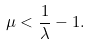<formula> <loc_0><loc_0><loc_500><loc_500>\mu < \frac { 1 } { \lambda } - 1 .</formula> 